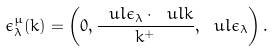<formula> <loc_0><loc_0><loc_500><loc_500>\epsilon ^ { \mu } _ { \lambda } ( k ) = \left ( 0 , \frac { \ u l { \epsilon } _ { \lambda } \cdot \ u l { k } } { k ^ { + } } , \ u l { \epsilon } _ { \lambda } \right ) .</formula> 